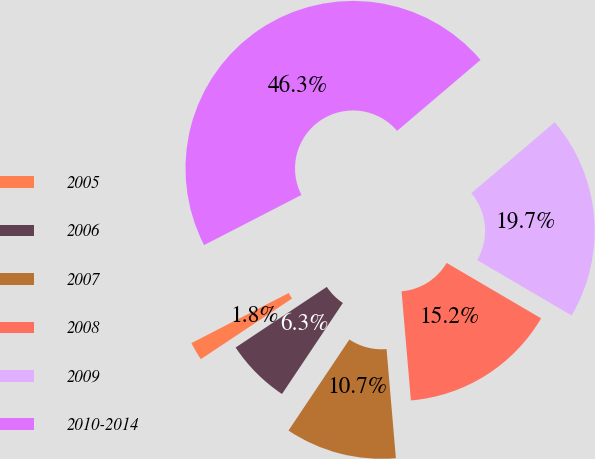Convert chart to OTSL. <chart><loc_0><loc_0><loc_500><loc_500><pie_chart><fcel>2005<fcel>2006<fcel>2007<fcel>2008<fcel>2009<fcel>2010-2014<nl><fcel>1.77%<fcel>6.28%<fcel>10.74%<fcel>15.2%<fcel>19.66%<fcel>46.35%<nl></chart> 